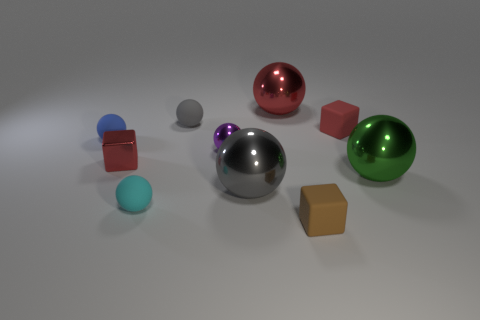Subtract all blue spheres. How many spheres are left? 6 Subtract all small gray rubber spheres. How many spheres are left? 6 Subtract all brown spheres. Subtract all gray cylinders. How many spheres are left? 7 Subtract all blocks. How many objects are left? 7 Subtract all tiny blue things. Subtract all tiny shiny objects. How many objects are left? 7 Add 8 tiny rubber cubes. How many tiny rubber cubes are left? 10 Add 3 gray metal blocks. How many gray metal blocks exist? 3 Subtract 0 green cylinders. How many objects are left? 10 